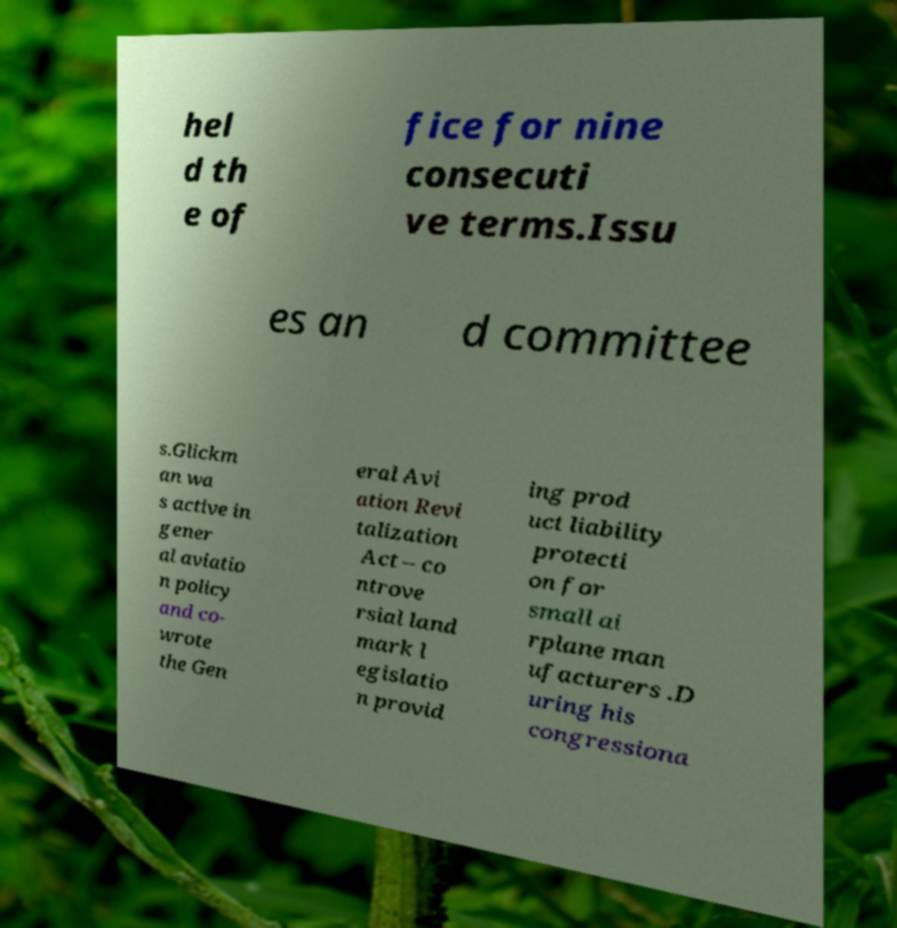For documentation purposes, I need the text within this image transcribed. Could you provide that? hel d th e of fice for nine consecuti ve terms.Issu es an d committee s.Glickm an wa s active in gener al aviatio n policy and co- wrote the Gen eral Avi ation Revi talization Act – co ntrove rsial land mark l egislatio n provid ing prod uct liability protecti on for small ai rplane man ufacturers .D uring his congressiona 